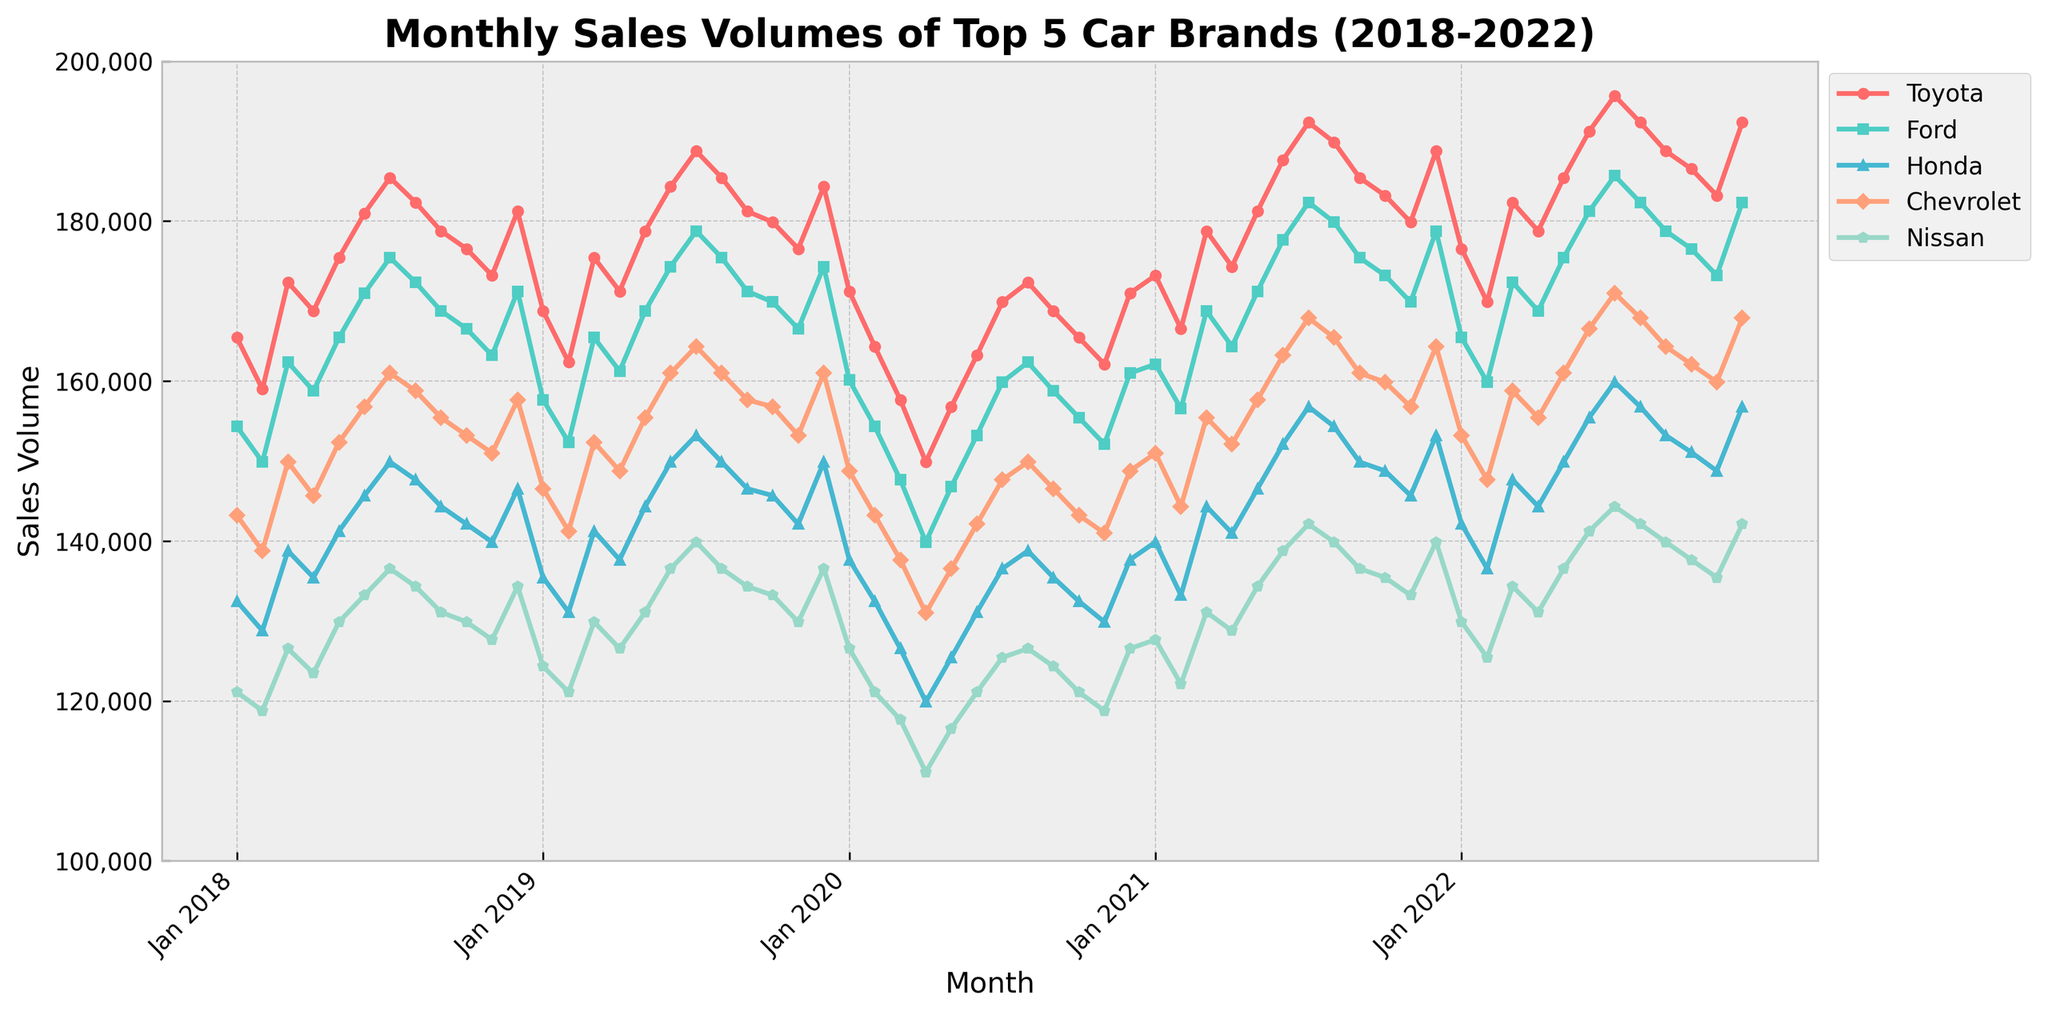Which brand had the highest peak in sales volume over the past 5 years? By observing the figure, look for the highest point among all brands. Toyota shows the highest peak in sales volume in July 2022, reaching around 195,678 units.
Answer: Toyota Between Mar 2019 and Jul 2019, which brand showed the largest increase in sales volume? We need to compare the sales volume between Mar 2019 and Jul 2019 for each brand. Toyota had the largest increase: from 175,432 in Mar 2019 to 188,765 in Jul 2019, an increase of 13,333 units.
Answer: Toyota What was the average sales volume for Honda in the year 2020? To find the average, sum up the monthly sales for Honda in 2020 and divide by 12. The yearly total is 1,632,708. The average is 1,632,708 / 12 = 136,059 units.
Answer: 136,059 Which month in 2022 did Chevrolet reach its highest sales volume, and what was the volume? By examining the chart, Chevrolet reached its highest sales volume in Jul 2022, with around 170,987 units.
Answer: July 2022, 170,987 How do the sales trends of Ford and Nissan compare from 2018 to 2022? Observing the figure, Ford and Nissan both show an upward trend towards the mid-2021, after which Nissan's sales slightly decreased, while Ford maintained an upward trend more steadily towards 2022.
Answer: Ford maintained an upward trend, Nissan slightly decreased after mid-2021 Which brand had the lowest sales volume in Apr 2020 and what was the volume? Look for the lowest point in April 2020. Chevrolet had the lowest sales volume at about 130,987 units in April 2020.
Answer: Chevrolet, 130,987 Among the top 5 car brands, which brand had the most stable sales volume between 2021 and 2022? By scrutinizing the figure, Honda shows the least fluctuation in its sales volumes across these years.
Answer: Honda In 2021, which month did Nissan experience the largest drop in sales volume compared to the previous month, and how much was the drop? Compare the monthly values for Nissan in 2021. Nissan saw the largest drop from July (142,109) to September (136,543), a drop of 5,566 units.
Answer: September 2021, 5,566 units When comparing Ford and Chevrolet in Dec 2019, how much higher were Chevrolet's sales volumes compared to Ford’s? Subtract Ford's sales volume from Chevrolet's for Dec 2019. Chevrolet had 160,987 – 174,321 = -13,334 units, so Ford's volume was higher by 13,334 units.
Answer: Ford 13,334 units higher What color is used to represent Toyota's sales trend, and what does it imply about its sales compared to other brands in the same figure? The figure shows Toyota's sales trend in red. The consistent high peaks and relatively high values imply that Toyota generally has higher sales compared to other brands over the past 5 years.
Answer: Red, higher sales 